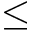<formula> <loc_0><loc_0><loc_500><loc_500>\leq</formula> 